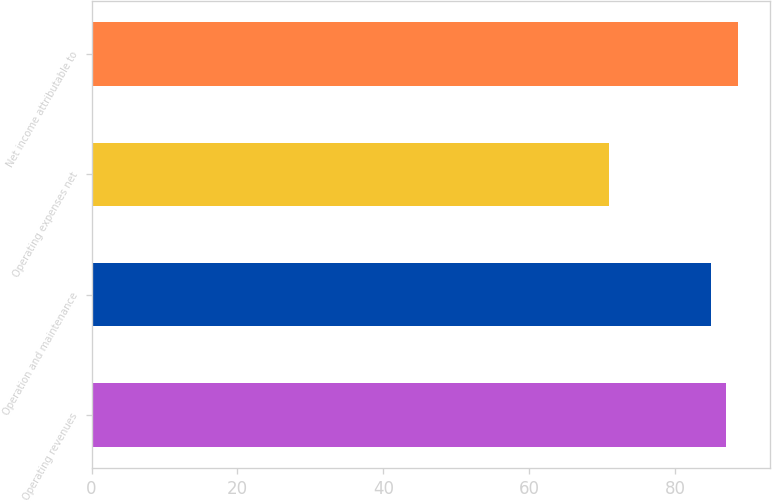<chart> <loc_0><loc_0><loc_500><loc_500><bar_chart><fcel>Operating revenues<fcel>Operation and maintenance<fcel>Operating expenses net<fcel>Net income attributable to<nl><fcel>87<fcel>85<fcel>71<fcel>88.6<nl></chart> 